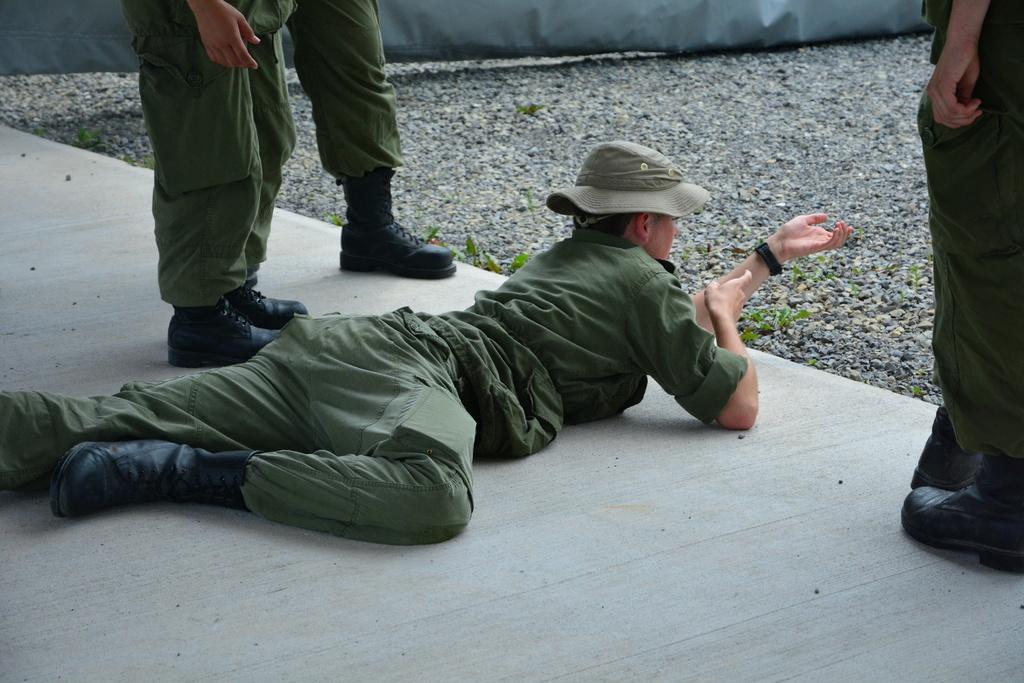How would you summarize this image in a sentence or two? In this image we can see a person wearing hat lying down on the floor. We can also see some plants, stones, a curtain and a group of people standing beside him. 